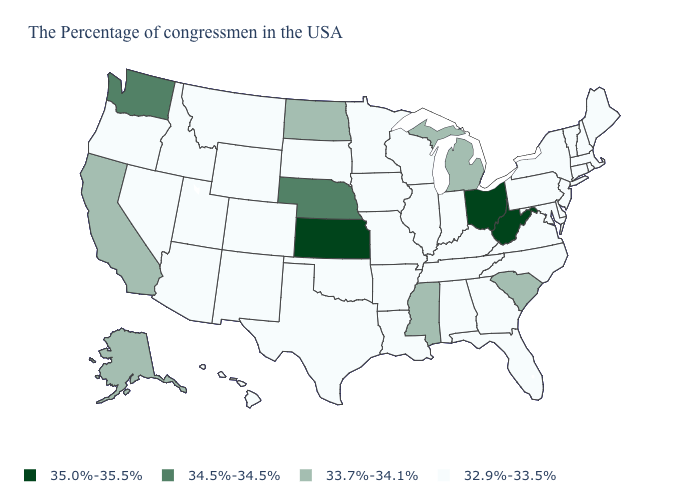Does the first symbol in the legend represent the smallest category?
Write a very short answer. No. Does Vermont have the same value as Florida?
Keep it brief. Yes. Name the states that have a value in the range 32.9%-33.5%?
Give a very brief answer. Maine, Massachusetts, Rhode Island, New Hampshire, Vermont, Connecticut, New York, New Jersey, Delaware, Maryland, Pennsylvania, Virginia, North Carolina, Florida, Georgia, Kentucky, Indiana, Alabama, Tennessee, Wisconsin, Illinois, Louisiana, Missouri, Arkansas, Minnesota, Iowa, Oklahoma, Texas, South Dakota, Wyoming, Colorado, New Mexico, Utah, Montana, Arizona, Idaho, Nevada, Oregon, Hawaii. Which states have the lowest value in the West?
Keep it brief. Wyoming, Colorado, New Mexico, Utah, Montana, Arizona, Idaho, Nevada, Oregon, Hawaii. What is the value of Oklahoma?
Write a very short answer. 32.9%-33.5%. Among the states that border Nebraska , which have the lowest value?
Keep it brief. Missouri, Iowa, South Dakota, Wyoming, Colorado. Does New York have the same value as South Carolina?
Keep it brief. No. What is the lowest value in the Northeast?
Concise answer only. 32.9%-33.5%. Which states have the highest value in the USA?
Quick response, please. West Virginia, Ohio, Kansas. What is the value of Maryland?
Give a very brief answer. 32.9%-33.5%. What is the highest value in the USA?
Keep it brief. 35.0%-35.5%. Name the states that have a value in the range 33.7%-34.1%?
Concise answer only. South Carolina, Michigan, Mississippi, North Dakota, California, Alaska. Does the map have missing data?
Quick response, please. No. What is the lowest value in the USA?
Short answer required. 32.9%-33.5%. Among the states that border Louisiana , does Arkansas have the highest value?
Short answer required. No. 